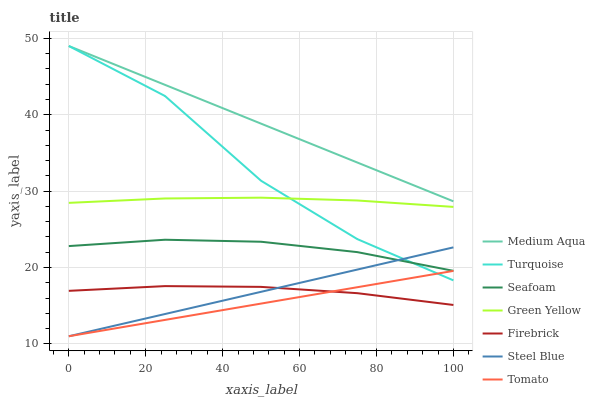Does Tomato have the minimum area under the curve?
Answer yes or no. Yes. Does Medium Aqua have the maximum area under the curve?
Answer yes or no. Yes. Does Turquoise have the minimum area under the curve?
Answer yes or no. No. Does Turquoise have the maximum area under the curve?
Answer yes or no. No. Is Steel Blue the smoothest?
Answer yes or no. Yes. Is Turquoise the roughest?
Answer yes or no. Yes. Is Firebrick the smoothest?
Answer yes or no. No. Is Firebrick the roughest?
Answer yes or no. No. Does Turquoise have the lowest value?
Answer yes or no. No. Does Medium Aqua have the highest value?
Answer yes or no. Yes. Does Firebrick have the highest value?
Answer yes or no. No. Is Steel Blue less than Green Yellow?
Answer yes or no. Yes. Is Medium Aqua greater than Steel Blue?
Answer yes or no. Yes. Does Medium Aqua intersect Turquoise?
Answer yes or no. Yes. Is Medium Aqua less than Turquoise?
Answer yes or no. No. Is Medium Aqua greater than Turquoise?
Answer yes or no. No. Does Steel Blue intersect Green Yellow?
Answer yes or no. No. 